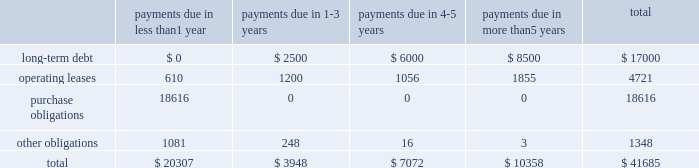Table of contents the table presents certain payments due by the company under contractual obligations with minimum firm commitments as of september 28 , 2013 and excludes amounts already recorded on the consolidated balance sheet , except for long-term debt ( in millions ) : lease commitments the company 2019s major facility leases are typically for terms not exceeding 10 years and generally provide renewal options for terms not exceeding five additional years .
Leases for retail space are for terms ranging from five to 20 years , the majority of which are for 10 years , and often contain multi-year renewal options .
As of september 28 , 2013 , the company 2019s total future minimum lease payments under noncancelable operating leases were $ 4.7 billion , of which $ 3.5 billion related to leases for retail space .
Purchase commitments with outsourcing partners and component suppliers the company utilizes several outsourcing partners to manufacture sub-assemblies for the company 2019s products and to perform final assembly and testing of finished products .
These outsourcing partners acquire components and build product based on demand information supplied by the company , which typically covers periods up to 150 days .
The company also obtains individual components for its products from a wide variety of individual suppliers .
Consistent with industry practice , the company acquires components through a combination of purchase orders , supplier contracts , and open orders based on projected demand information .
Where appropriate , the purchases are applied to inventory component prepayments that are outstanding with the respective supplier .
As of september 28 , 2013 , the company had outstanding off-balance sheet third- party manufacturing commitments and component purchase commitments of $ 18.6 billion .
Other obligations in addition to the off-balance sheet commitments mentioned above , the company had outstanding obligations of $ 1.3 billion as of september 28 , 2013 , that consisted mainly of commitments to acquire capital assets , including product tooling and manufacturing process equipment , and commitments related to advertising , research and development , internet and telecommunications services and other obligations .
The company 2019s other non-current liabilities in the consolidated balance sheets consist primarily of deferred tax liabilities , gross unrecognized tax benefits and the related gross interest and penalties .
As of september 28 , 2013 , the company had non-current deferred tax liabilities of $ 16.5 billion .
Additionally , as of september 28 , 2013 , the company had gross unrecognized tax benefits of $ 2.7 billion and an additional $ 590 million for gross interest and penalties classified as non-current liabilities .
At this time , the company is unable to make a reasonably reliable estimate of the timing of payments in individual years in connection with these tax liabilities ; therefore , such amounts are not included in the above contractual obligation table .
Indemnification the company generally does not indemnify end-users of its operating system and application software against legal claims that the software infringes third-party intellectual property rights .
Other agreements entered into by payments due in than 1 payments due in payments due in payments due in than 5 years total .

What percentage of certain payments due by the company under contractual obligations consisted of purchase obligations? 
Computations: (18616 / 41685)
Answer: 0.44659. 